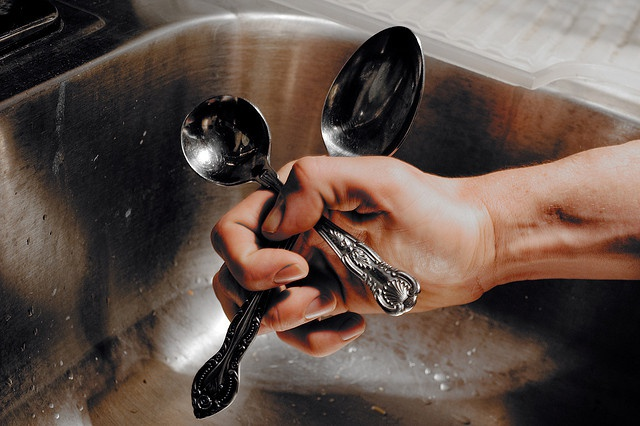Describe the objects in this image and their specific colors. I can see sink in black, maroon, and gray tones, people in black, tan, and brown tones, spoon in black, gray, darkgray, and lightgray tones, and spoon in black, gray, and darkgray tones in this image. 